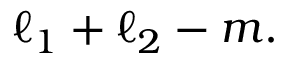<formula> <loc_0><loc_0><loc_500><loc_500>\ell _ { 1 } + \ell _ { 2 } - m .</formula> 